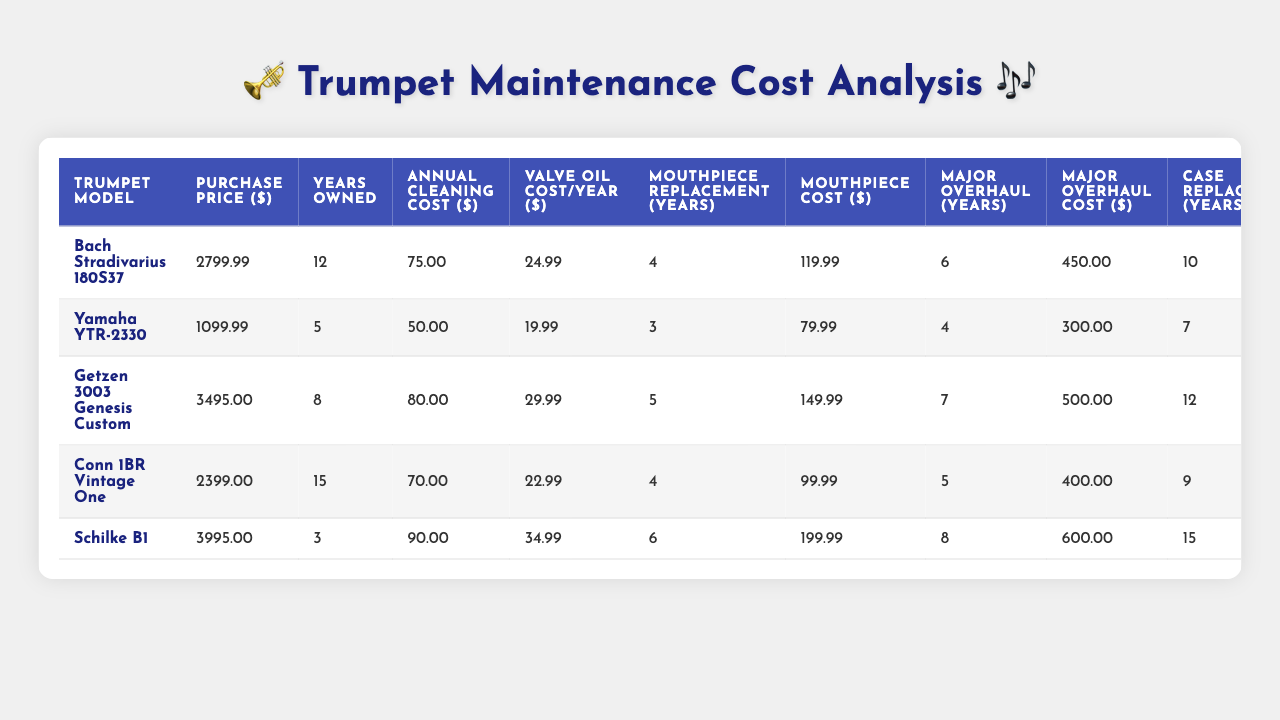What is the purchase price of the Yamaha YTR-2330? The table lists the purchase prices for all trumpet models. The price for the Yamaha YTR-2330 is directly stated in the table as $1099.99.
Answer: 1099.99 How many years has the Conn 1BR Vintage One been owned? The table provides the 'Years Owned' for each trumpet model. For the Conn 1BR Vintage One, it shows 15 years.
Answer: 15 What is the total annual maintenance cost for the Getzen 3003 Genesis Custom? The annual maintenance cost includes the annual cleaning cost and the valve oil cost. For the Getzen 3003 Genesis Custom, the annual cleaning cost is $80.00 and the valve oil cost is $29.99, so the total is $80.00 + $29.99 = $109.99.
Answer: 109.99 Which trumpet model has the highest resale value percentage? The resale value percentages are in the table, and the model with the highest percentage is the Schilke B1 at 70%.
Answer: Schilke B1 What is the average mouthpiece replacement frequency for the trumpets? To find the average, sum the mouthpiece replacement frequencies (4 + 3 + 5 + 4 + 6 = 22) and divide by the number of models (5). The average is 22 / 5 = 4.4 years.
Answer: 4.4 Is the annual cleaning cost higher for the Bach Stradivarius 180S37 compared to the Yamaha YTR-2330? The table shows that the annual cleaning cost for the Bach Stradivarius 180S37 is $75.00, while the cost for the Yamaha YTR-2330 is $50.00. Since $75.00 is greater than $50.00, the answer is yes.
Answer: Yes How often is a major overhaul required for the Schilke B1? The frequency of major overhauls for the Schilke B1 is listed in the table as every 8 years.
Answer: 8 years Calculate the total cost of ownership for the First 12 years for the Bach Stradivarius 180S37. First, calculate annual cost: Annual cleaning = $75.00, Valve oil = $24.99; Total annual = $75.00 + $24.99 = $99.99. Over 12 years = $99.99 * 12 = $1198.88. Major overhauls = 2 (every 6 years) * $450 = $900. Total cost of ownership = $1198.88 + $900 = $2098.88.
Answer: 2098.88 Which trumpet had the lowest purchase price? By examining the purchase prices listed, the lowest price is for the Yamaha YTR-2330 at $1099.99.
Answer: Yamaha YTR-2330 What is the cost incurred for additional cleaning for outdoor gigs annually for the Conn 1BR Vintage One? For the Conn 1BR Vintage One, there are 18 outdoor gigs per year and the additional cleaning cost is $4.50 per gig. Thus, total additional cleaning cost = 18 * $4.50 = $81.00 annually.
Answer: 81.00 